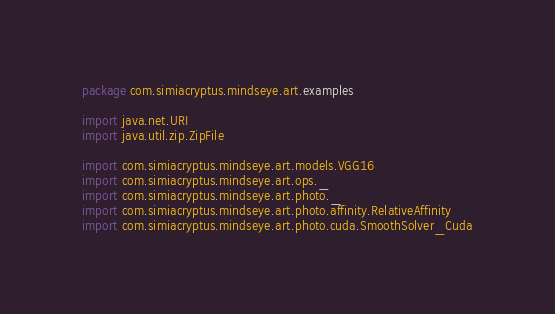Convert code to text. <code><loc_0><loc_0><loc_500><loc_500><_Scala_>package com.simiacryptus.mindseye.art.examples

import java.net.URI
import java.util.zip.ZipFile

import com.simiacryptus.mindseye.art.models.VGG16
import com.simiacryptus.mindseye.art.ops._
import com.simiacryptus.mindseye.art.photo._
import com.simiacryptus.mindseye.art.photo.affinity.RelativeAffinity
import com.simiacryptus.mindseye.art.photo.cuda.SmoothSolver_Cuda</code> 